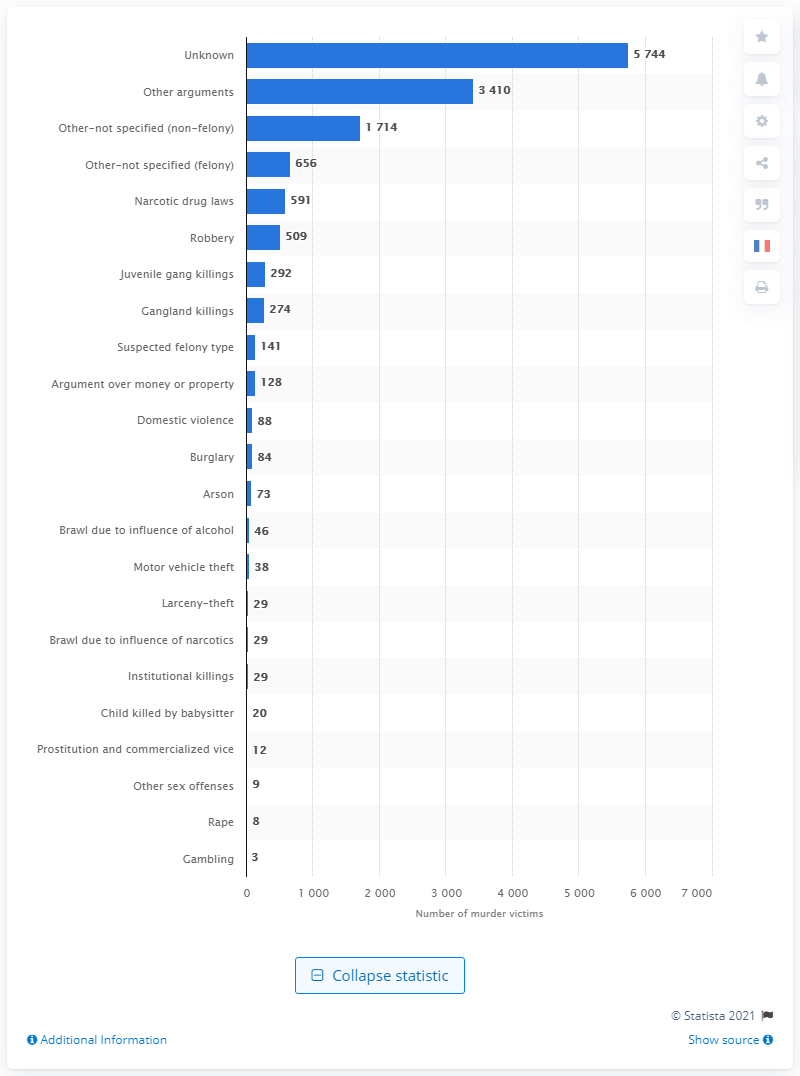List a handful of essential elements in this visual. In 2019, 73 people were killed as a result of arson. In 2019, a total of 509 individuals were killed as a result of robberies. 